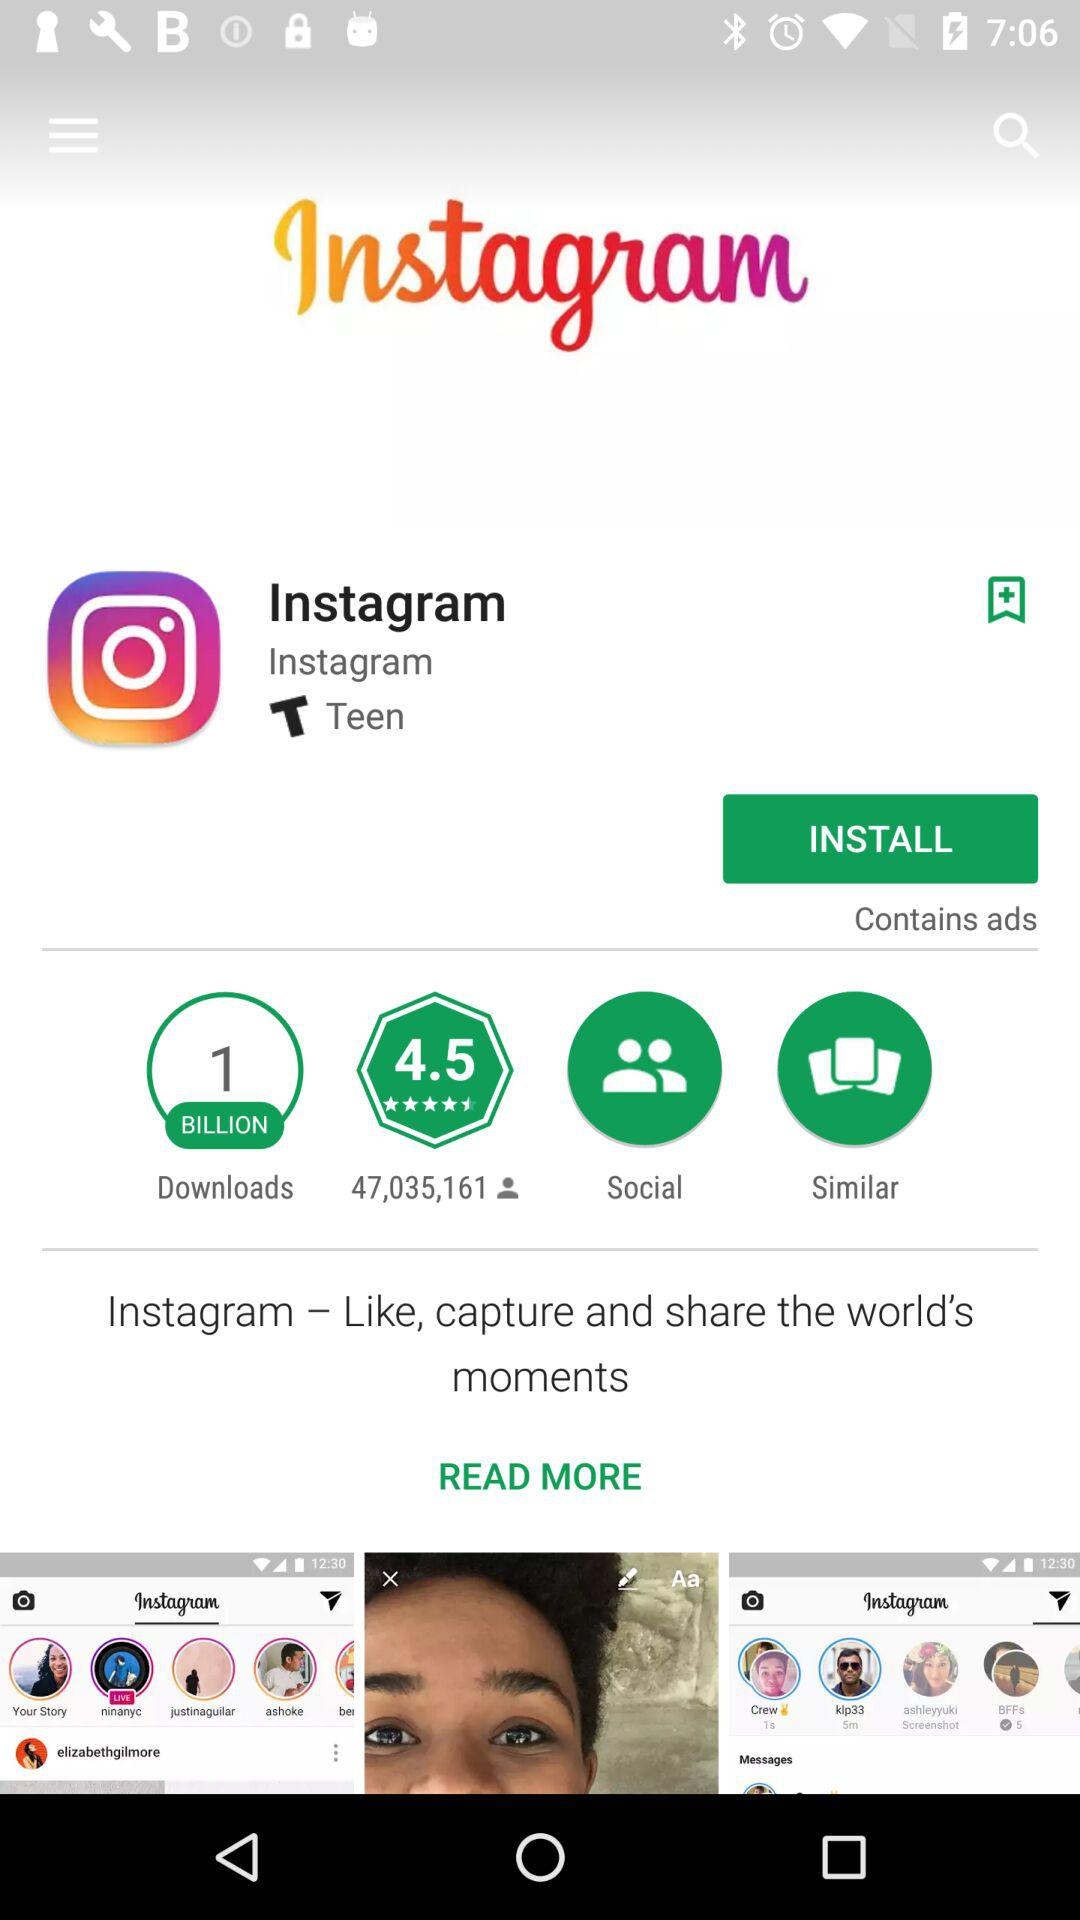How many people downloaded the application? The image clearly shows that the Instagram application has been downloaded 1 billion times. This milestone reflects its popularity and widespread use around the globe. 